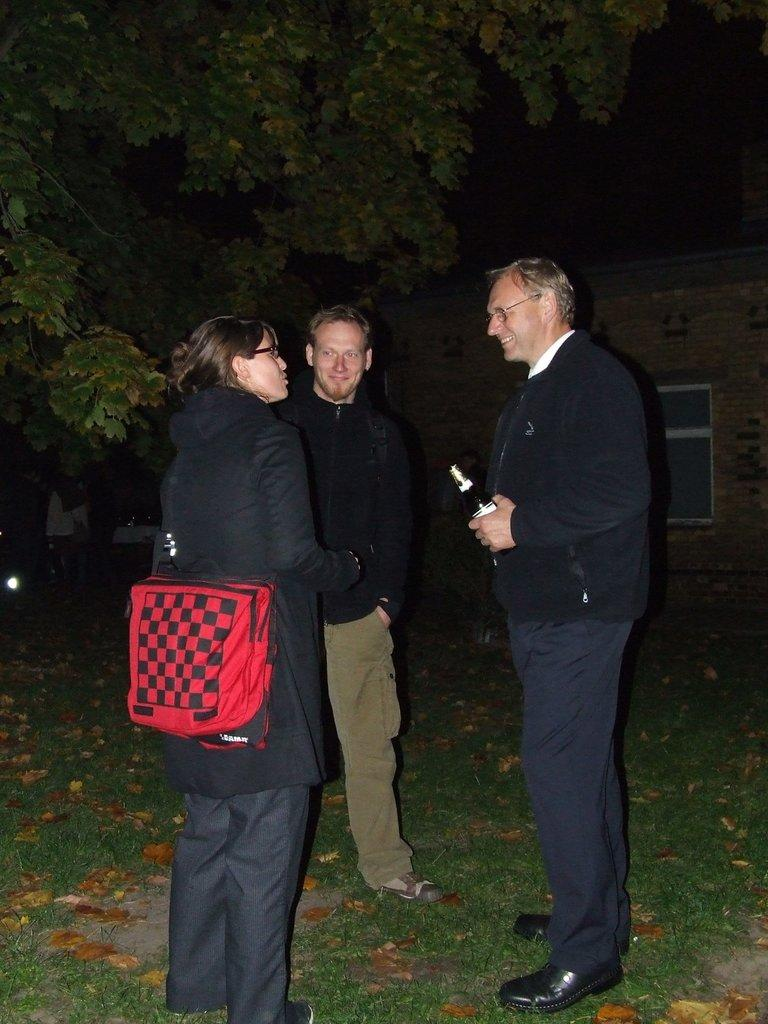What are the people in the image doing? The people in the image are standing on the ground. What object are the people holding? The people are holding a bottle. What type of vegetation can be seen in the image? There is grass visible in the image, as well as leaves and trees. What type of structure is present in the image? There is a building in the image. What type of peace symbol can be seen in the image? There is no peace symbol present in the image. In which bedroom are the people standing in the image? The image does not show a bedroom or any indication of an indoor setting. 